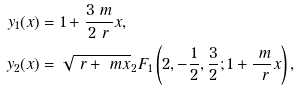Convert formula to latex. <formula><loc_0><loc_0><loc_500><loc_500>y _ { 1 } ( x ) & = 1 + \frac { 3 \ m } { 2 \ r } x , \\ y _ { 2 } ( x ) & = \sqrt { \ r + \ m x } _ { 2 } F _ { 1 } \left ( 2 , - \frac { 1 } { 2 } , \frac { 3 } { 2 } ; 1 + \frac { \ m } { \ r } x \right ) ,</formula> 